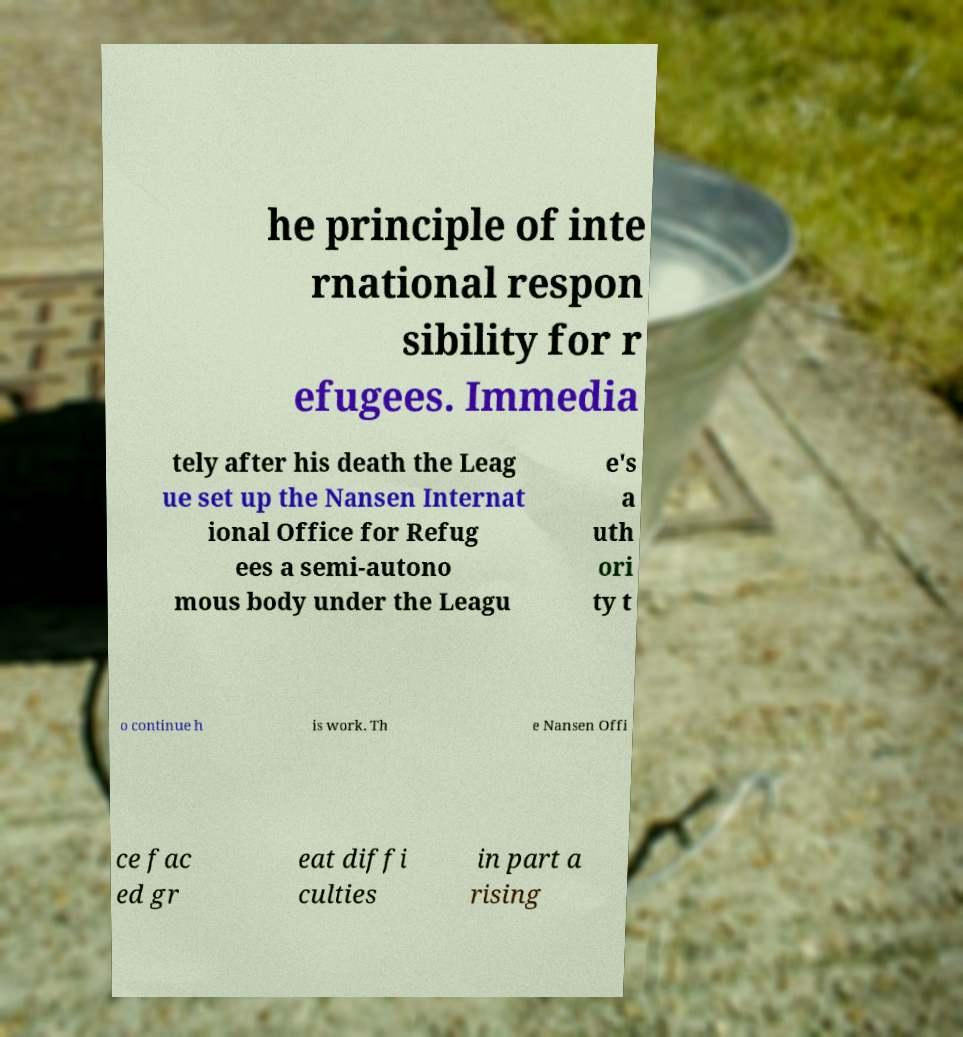Can you accurately transcribe the text from the provided image for me? he principle of inte rnational respon sibility for r efugees. Immedia tely after his death the Leag ue set up the Nansen Internat ional Office for Refug ees a semi-autono mous body under the Leagu e's a uth ori ty t o continue h is work. Th e Nansen Offi ce fac ed gr eat diffi culties in part a rising 